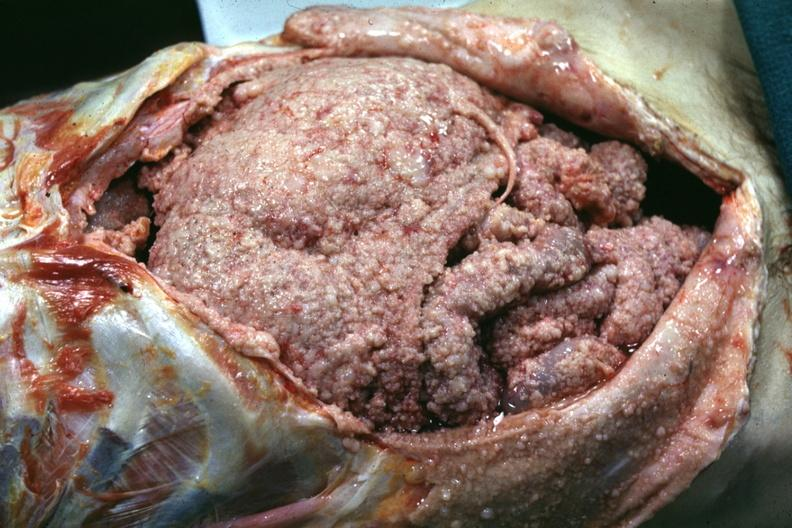what is present?
Answer the question using a single word or phrase. Peritoneum 